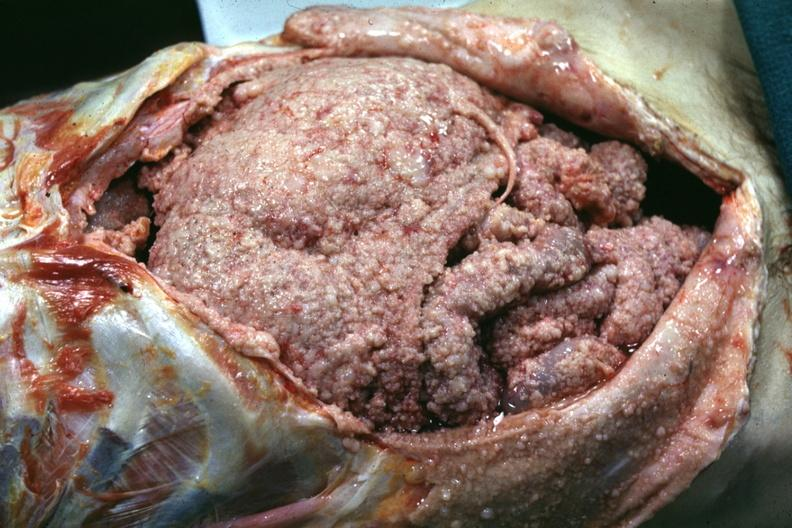what is present?
Answer the question using a single word or phrase. Peritoneum 